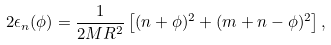<formula> <loc_0><loc_0><loc_500><loc_500>2 \epsilon _ { n } ( \phi ) = \frac { 1 } { 2 M R ^ { 2 } } \left [ ( n + \phi ) ^ { 2 } + ( m + n - \phi ) ^ { 2 } \right ] ,</formula> 